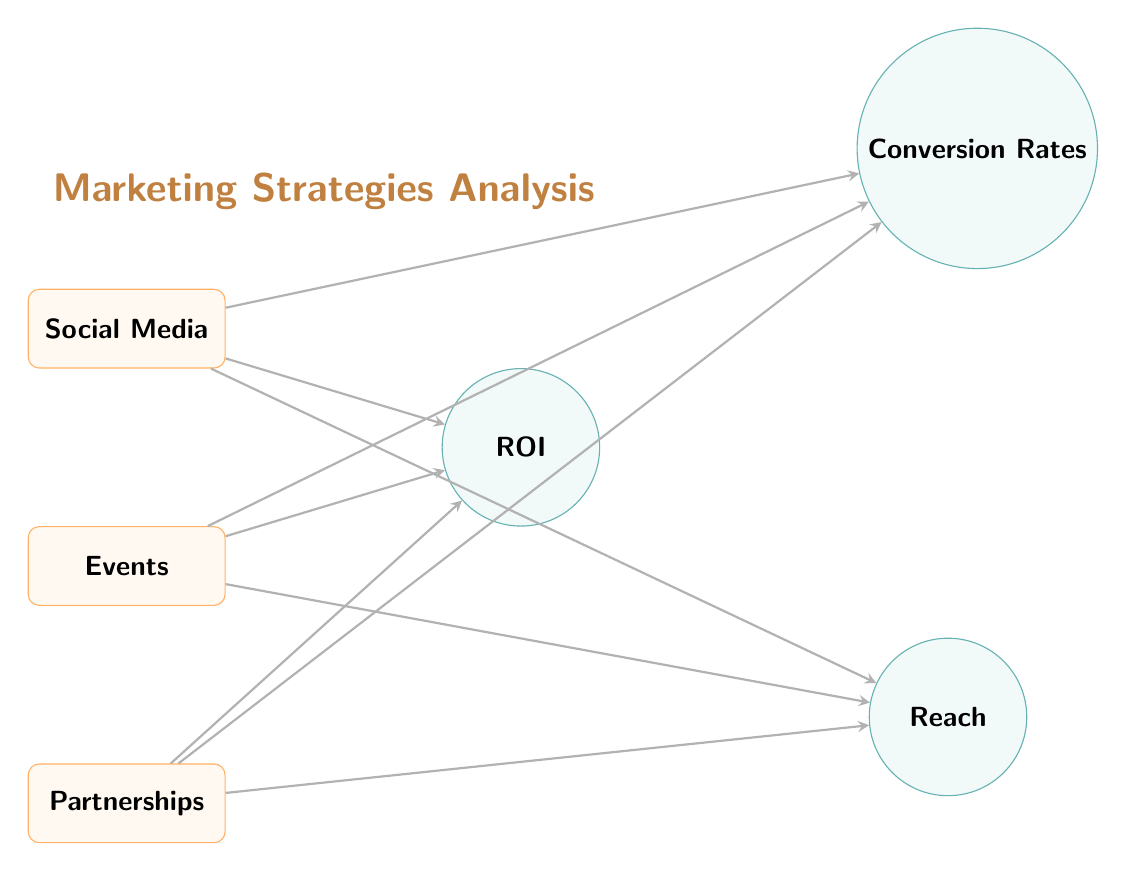What are the three marketing strategies shown? The diagram lists three marketing strategies that are shown as nodes: Social Media, Events, and Partnerships.
Answer: Social Media, Events, Partnerships How many metrics are associated with the marketing strategies? The diagram indicates three metrics connected to the marketing strategies: ROI, Conversion Rates, and Reach. Therefore, the total is three metrics.
Answer: 3 Which strategy connects to the highest metric? The diagram does not indicate any metric measurements; thus, it does not specify which strategy connects to the highest metric. Each strategy connects to all three metrics.
Answer: N/A What is the relationship between Events and Conversion Rates? Events is directly connected to Conversion Rates through an arrow, indicating that Events influence or relate to Conversion Rates.
Answer: Direct Which metric is located at the upper right position? In the diagram, the metric located at the upper right position is identified as Conversion Rates.
Answer: Conversion Rates How many edges are shown in the diagram? Since each of the three marketing strategies connects to each of the three metrics, we have a total of nine edges, as each strategy has three outgoing arrows.
Answer: 9 Which marketing strategy connects to the metric Reach? Events, Social Media, and Partnerships all connect to the metric Reach as indicated by the arrows from each strategy to the Reach node.
Answer: All strategies What does the central label state? The central label positioned above the marketing strategies indicates "Marketing Strategies Analysis."
Answer: Marketing Strategies Analysis 